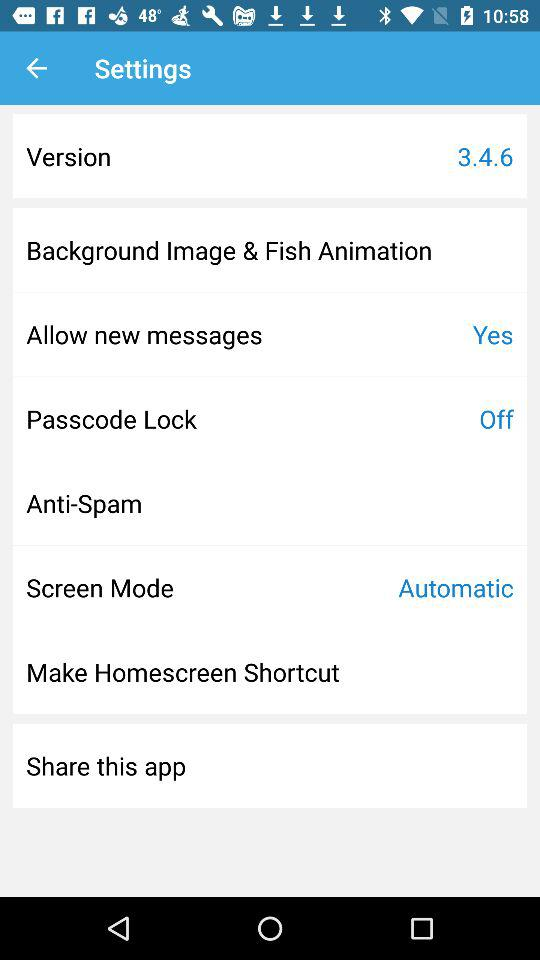What is the version? The version is 3.4.6. 